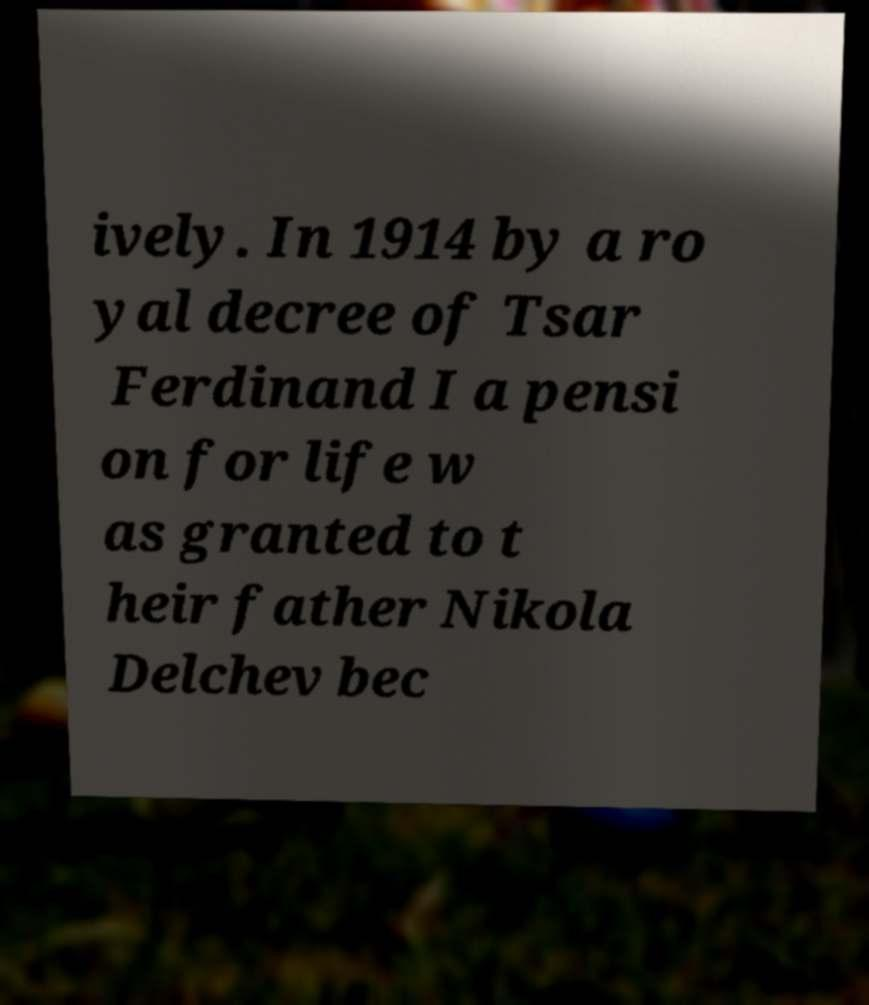Could you assist in decoding the text presented in this image and type it out clearly? ively. In 1914 by a ro yal decree of Tsar Ferdinand I a pensi on for life w as granted to t heir father Nikola Delchev bec 